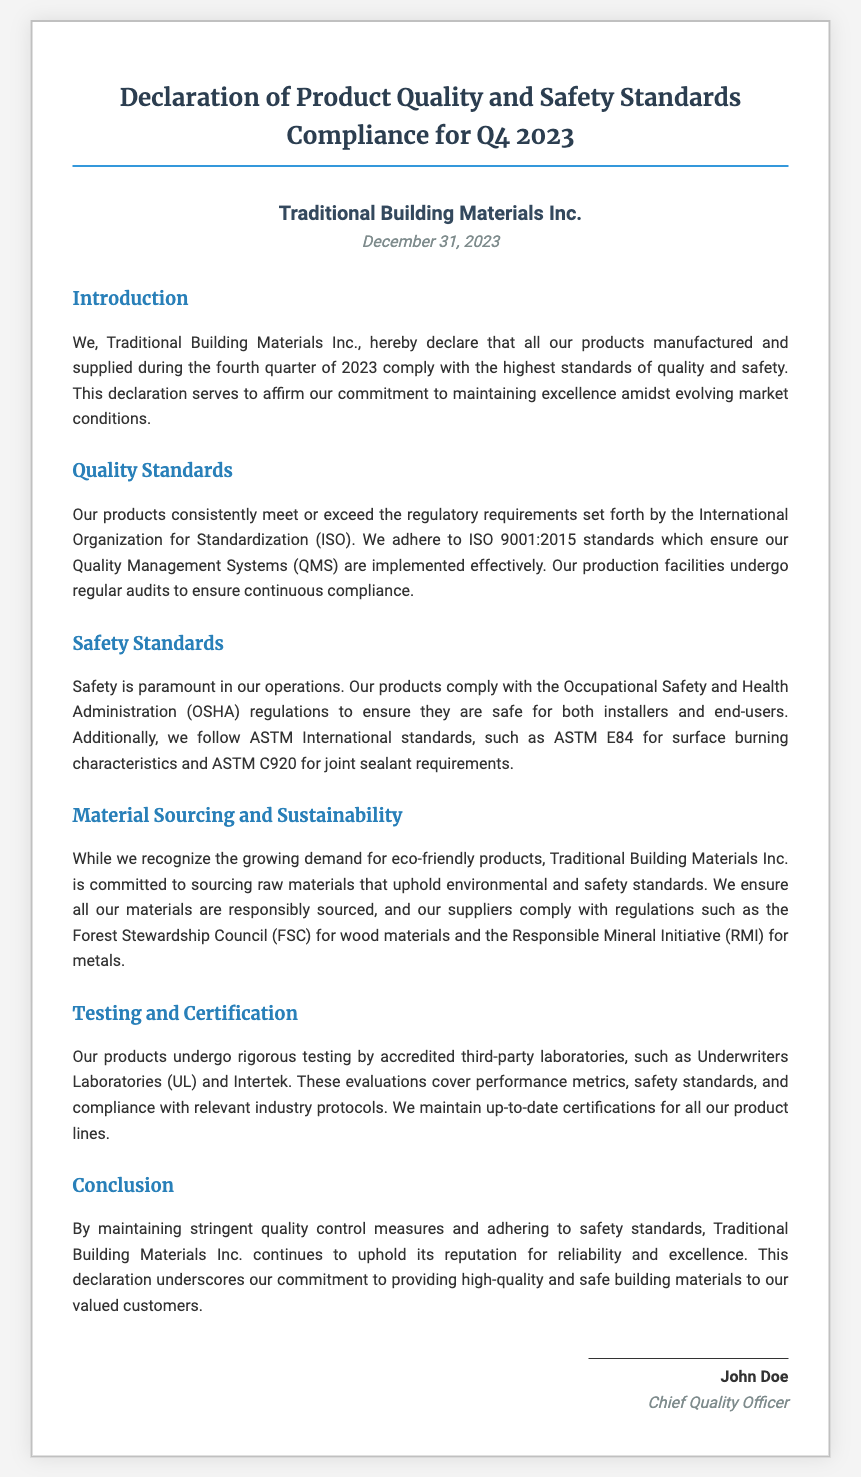What is the name of the company? The company name is stated at the top of the document in the company info section.
Answer: Traditional Building Materials Inc What is the declaration date? The declaration date is mentioned in the company info section below the company name.
Answer: December 31, 2023 Which standard is referenced for quality management systems? The document specifies the standard that the company's quality management systems adhere to in the Quality Standards section.
Answer: ISO 9001:2015 Who is the signatory of the declaration? The signatory's name is found at the end of the document in the signature section.
Answer: John Doe What is the position of the signatory? This information is given next to the signatory's name in the signature section.
Answer: Chief Quality Officer Which organization’s regulations are followed for safety? The document explicitly mentions the organization whose regulations are adhered to in the Safety Standards section.
Answer: Occupational Safety and Health Administration (OSHA) What kind of testing do the products undergo? The document mentions the type of testing and who performs it in the Testing and Certification section.
Answer: Rigorous testing What sustainability initiative is mentioned for wood materials? The relevant initiative for sourcing wood materials is described in the Material Sourcing and Sustainability section.
Answer: Forest Stewardship Council (FSC) What does the conclusion emphasize? The conclusion summarizes the company's commitment described in the last section of the document.
Answer: Reputation for reliability and excellence 